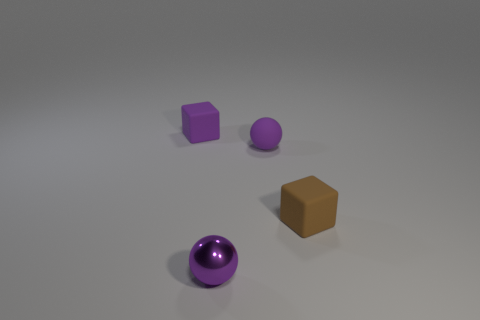Subtract all purple blocks. How many blocks are left? 1 Subtract 1 cubes. How many cubes are left? 1 Subtract all red cylinders. How many purple cubes are left? 1 Subtract all small blocks. Subtract all brown cubes. How many objects are left? 1 Add 4 brown cubes. How many brown cubes are left? 5 Add 1 tiny objects. How many tiny objects exist? 5 Add 3 purple things. How many objects exist? 7 Subtract 0 green blocks. How many objects are left? 4 Subtract all blue balls. Subtract all purple cubes. How many balls are left? 2 